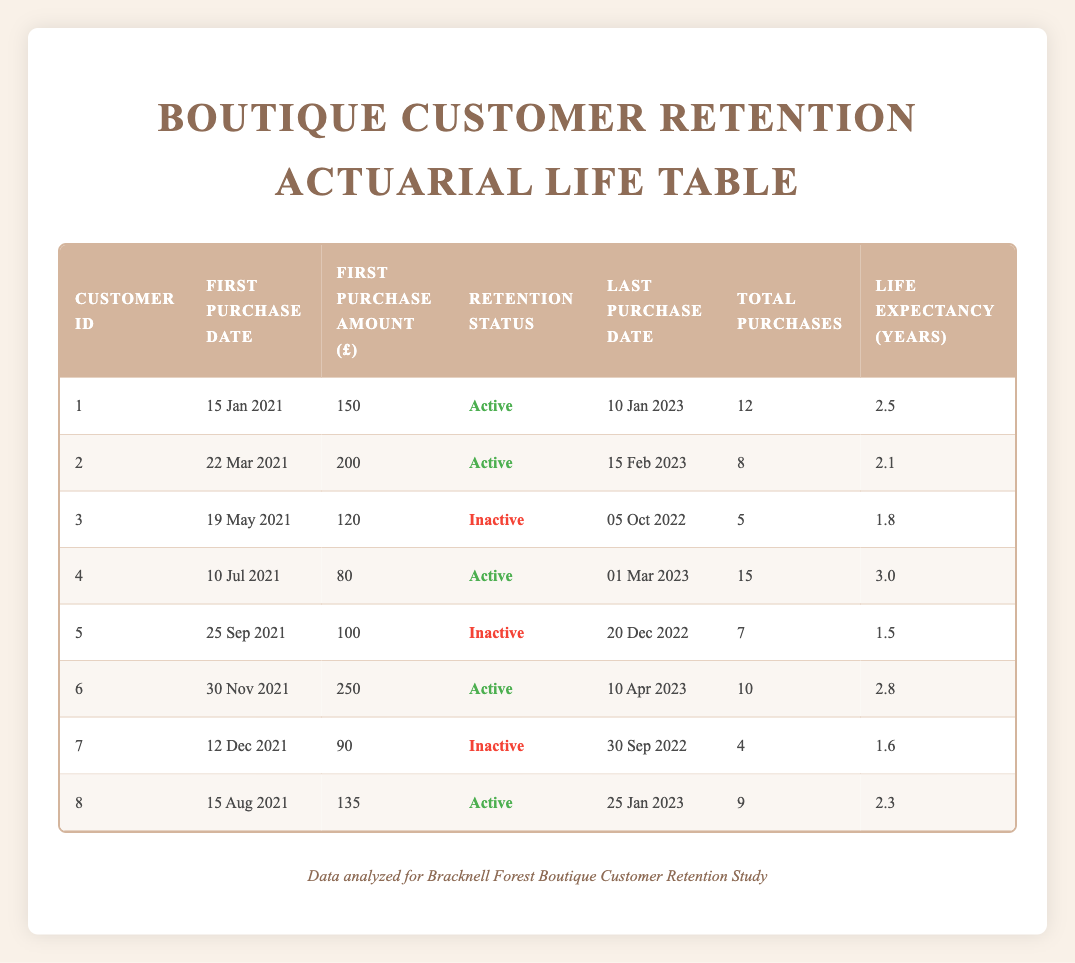What is the last purchase date of customer with ID 4? Looking at row 4 in the table, the last purchase date listed for customer ID 4 is "01 Mar 2023".
Answer: 01 Mar 2023 Which customer has the highest purchase amount? Row 6 shows that customer ID 6 made a purchase of £250, which is the highest amount when compared to other purchase amounts in the table.
Answer: £250 How many customers are currently active? From the retention status column, I can see four customers (IDs 1, 2, 4, 6, and 8) have the status "Active."
Answer: 5 What is the average life expectancy of purchases for active customers? The life expectancy years for active customers are (2.5 + 2.1 + 3.0 + 2.8 + 2.3) = 12.7. Since there are 5 active customers, the average life expectancy is 12.7 / 5 = 2.54 years.
Answer: 2.54 years Is customer ID 3 currently active? The retention status in row 3 specifies "Inactive" for customer ID 3, indicating that this customer is not currently active in making purchases.
Answer: No What is the total number of purchases made by customer ID 2? In row 2, the total purchases for customer ID 2 are recorded as 8, making it easy to retrieve this data directly from the table.
Answer: 8 Which active customer has the highest total number of purchases? By looking at the total purchases column for active customers (IDs 1, 2, 4, 6, and 8), customer ID 4 has 15 total purchases, which is more than others.
Answer: Customer ID 4 What is the life expectancy difference between the most and least active customers? The active customers have life expectancies: 2.5 (ID 1), 2.1 (ID 2), 3.0 (ID 4), 2.8 (ID 6), 2.3 (ID 8). The highest is 3.0 (ID 4), and the lowest is 2.1 (ID 2). The difference is 3.0 - 2.1 = 0.9 years.
Answer: 0.9 years 